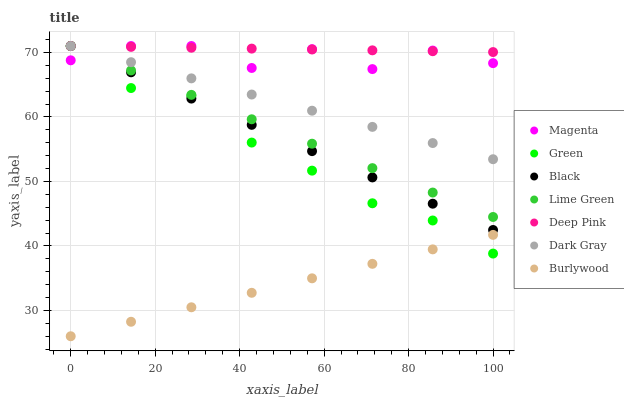Does Burlywood have the minimum area under the curve?
Answer yes or no. Yes. Does Deep Pink have the maximum area under the curve?
Answer yes or no. Yes. Does Dark Gray have the minimum area under the curve?
Answer yes or no. No. Does Dark Gray have the maximum area under the curve?
Answer yes or no. No. Is Deep Pink the smoothest?
Answer yes or no. Yes. Is Magenta the roughest?
Answer yes or no. Yes. Is Burlywood the smoothest?
Answer yes or no. No. Is Burlywood the roughest?
Answer yes or no. No. Does Burlywood have the lowest value?
Answer yes or no. Yes. Does Dark Gray have the lowest value?
Answer yes or no. No. Does Lime Green have the highest value?
Answer yes or no. Yes. Does Burlywood have the highest value?
Answer yes or no. No. Is Burlywood less than Black?
Answer yes or no. Yes. Is Black greater than Burlywood?
Answer yes or no. Yes. Does Dark Gray intersect Green?
Answer yes or no. Yes. Is Dark Gray less than Green?
Answer yes or no. No. Is Dark Gray greater than Green?
Answer yes or no. No. Does Burlywood intersect Black?
Answer yes or no. No. 